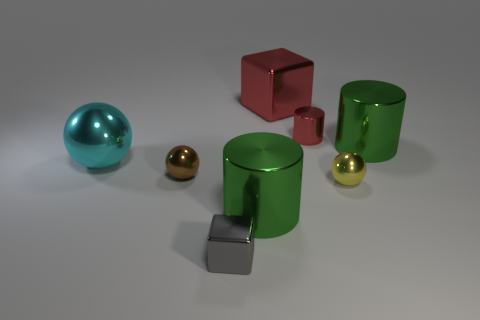Does the brown object have the same material as the block to the right of the tiny shiny cube?
Provide a succinct answer. Yes. How many things are either objects behind the small gray block or tiny red metal cubes?
Your answer should be very brief. 7. How big is the block that is right of the large metallic cylinder in front of the small shiny ball that is to the left of the tiny metallic cube?
Your response must be concise. Large. What material is the big block that is the same color as the tiny metal cylinder?
Offer a terse response. Metal. Is there any other thing that has the same shape as the big red thing?
Give a very brief answer. Yes. There is a metallic block that is behind the metallic block that is in front of the big red shiny thing; what size is it?
Offer a very short reply. Large. How many small objects are either green rubber cylinders or red objects?
Offer a very short reply. 1. Is the number of big red cubes less than the number of large purple cylinders?
Provide a succinct answer. No. Are there any other things that have the same size as the red cube?
Your answer should be compact. Yes. Is the color of the small metallic cylinder the same as the big ball?
Give a very brief answer. No. 